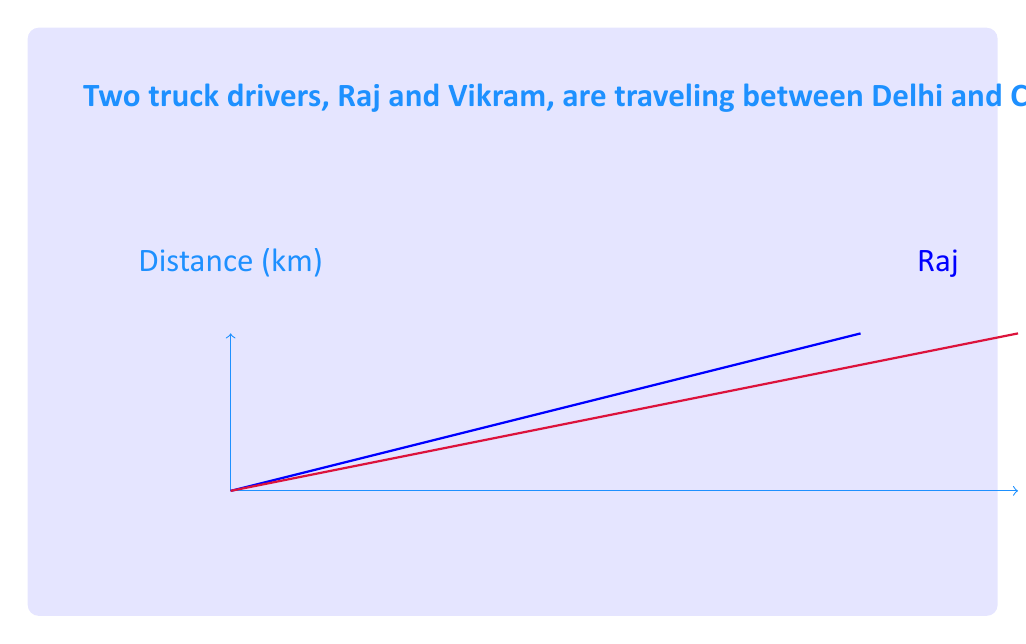Can you solve this math problem? Let's approach this step-by-step:

1) First, let's calculate the average speeds of Raj and Vikram:

   Raj's speed: $\frac{250 \text{ km}}{4 \text{ hours}} = 62.5 \text{ km/h}$
   Vikram's speed: $\frac{250 \text{ km}}{5 \text{ hours}} = 50 \text{ km/h}$

2) The ratio of their speeds is:
   
   $\frac{\text{Raj's speed}}{\text{Vikram's speed}} = \frac{62.5}{50} = \frac{5}{4} = 1.25:1$

3) If Raj's speed is increased by 20%, his new speed would be:
   
   $62.5 \text{ km/h} \times 1.2 = 75 \text{ km/h}$

4) To find how long it would take Raj at this new speed, we use the formula:
   
   $\text{Time} = \frac{\text{Distance}}{\text{Speed}}$

   $\text{Time} = \frac{250 \text{ km}}{75 \text{ km/h}} = \frac{10}{3} \text{ hours} = 3.\overline{3} \text{ hours}$

Therefore, at the increased speed, Raj would complete the journey in 3 hours and 20 minutes.
Answer: Ratio of speeds: $5:4$; New time for Raj: $3.\overline{3}$ hours 